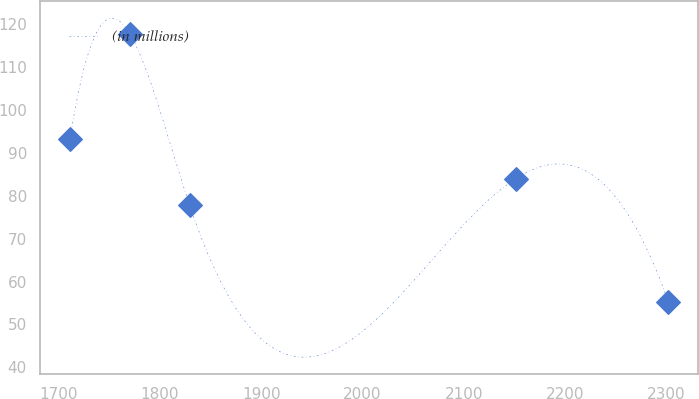Convert chart. <chart><loc_0><loc_0><loc_500><loc_500><line_chart><ecel><fcel>(in millions)<nl><fcel>1711.18<fcel>93.31<nl><fcel>1770.24<fcel>117.79<nl><fcel>1829.3<fcel>77.79<nl><fcel>2151.33<fcel>84.03<nl><fcel>2301.75<fcel>55.36<nl></chart> 